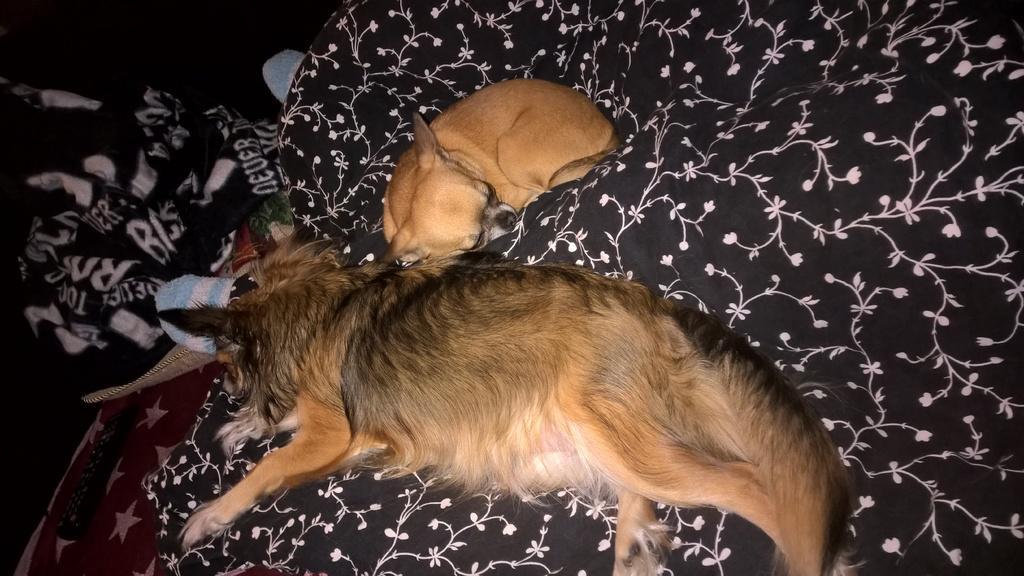Could you give a brief overview of what you see in this image? In the image there are two dogs laying on a black and white cloth, beside that there is a remote kept on a red and white cloth and there is another black and white cloth in front of the dogs and the background is dark. 